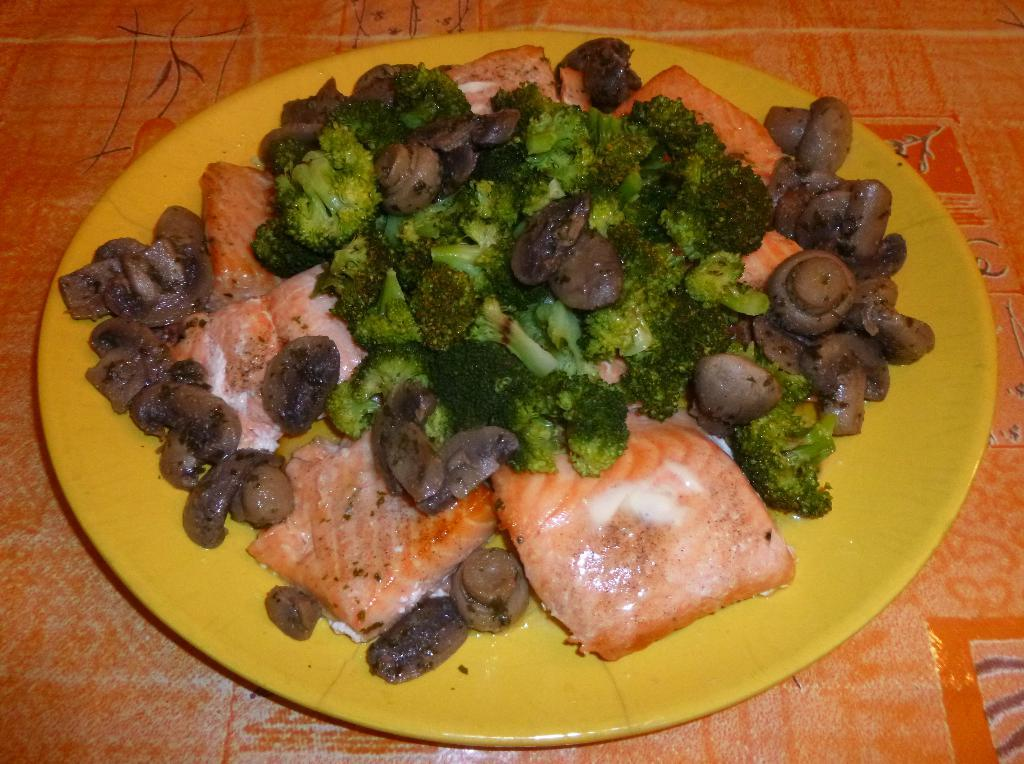What is present in the image related to food? There is food in the image. How is the food arranged or presented? The food is placed on a plate. What is the color of the plate? The plate is yellow in color. What piece of furniture is visible in the image? There is a table in the image. Is there a veil covering the food in the image? No, there is no veil present in the image. How does the lock on the plate affect the digestion of the food? There is no lock on the plate, and the digestion of the food is not affected by any lock. 